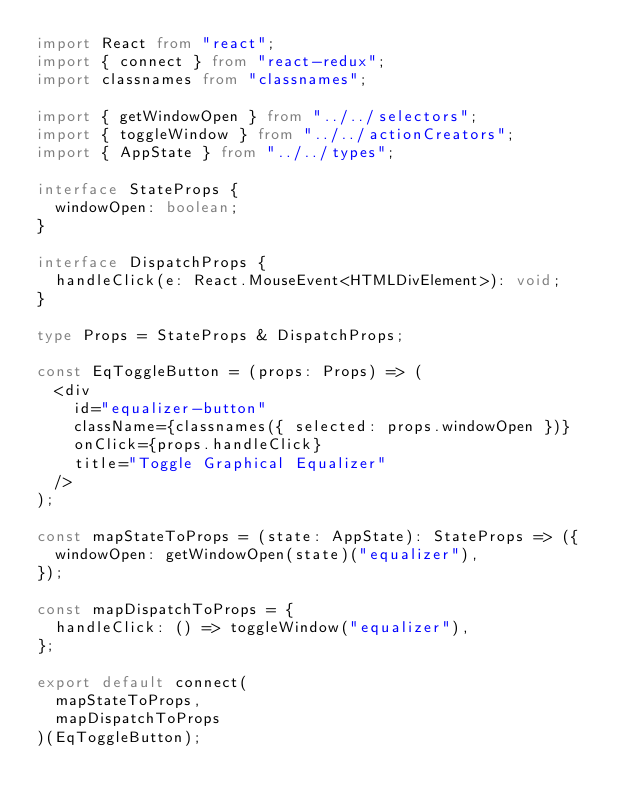<code> <loc_0><loc_0><loc_500><loc_500><_TypeScript_>import React from "react";
import { connect } from "react-redux";
import classnames from "classnames";

import { getWindowOpen } from "../../selectors";
import { toggleWindow } from "../../actionCreators";
import { AppState } from "../../types";

interface StateProps {
  windowOpen: boolean;
}

interface DispatchProps {
  handleClick(e: React.MouseEvent<HTMLDivElement>): void;
}

type Props = StateProps & DispatchProps;

const EqToggleButton = (props: Props) => (
  <div
    id="equalizer-button"
    className={classnames({ selected: props.windowOpen })}
    onClick={props.handleClick}
    title="Toggle Graphical Equalizer"
  />
);

const mapStateToProps = (state: AppState): StateProps => ({
  windowOpen: getWindowOpen(state)("equalizer"),
});

const mapDispatchToProps = {
  handleClick: () => toggleWindow("equalizer"),
};

export default connect(
  mapStateToProps,
  mapDispatchToProps
)(EqToggleButton);
</code> 